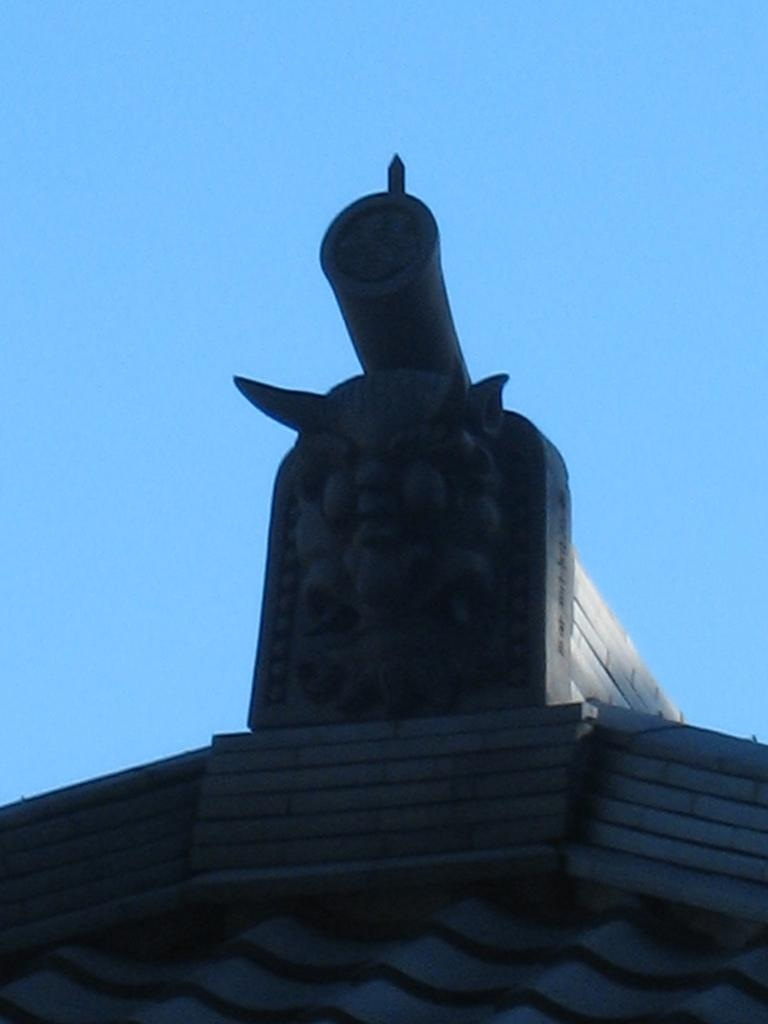What type of structure is present in the image? There is a concrete structure in the image. Where is the concrete structure located? The concrete structure is on a building. What can be seen in the background of the image? The sky is visible in the background of the image. What type of eggnog is being served at the writer's desk in the image? There is no writer or eggnog present in the image. The image only features a concrete structure on a building with the sky visible in the background. 